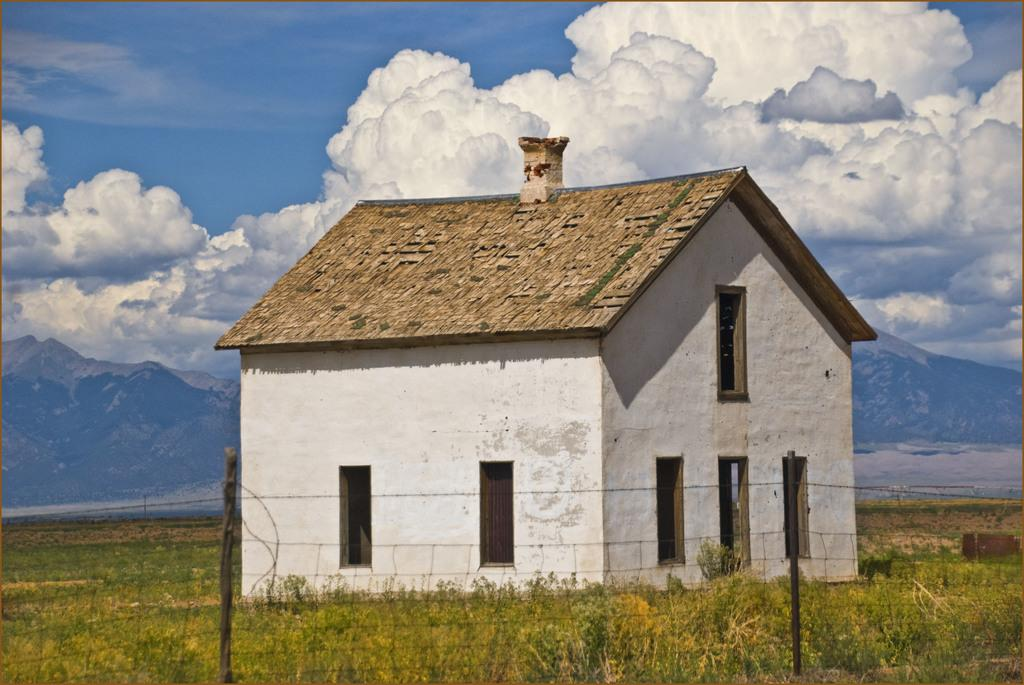What is the main subject of the image? There is a house at the center of the image. What type of vegetation is in front of the house? There is grass in front of the house. What can be seen in the background of the image? There is a sky visible in the background of the image. What is the condition of the sky in the image? Clouds are present in the sky. What type of lumber is used to construct the house in the image? There is no information about the type of lumber used to construct the house in the image. What flavor of yarn is being used to knit the clouds in the image? There are no yarn or knitting depicted in the image. 